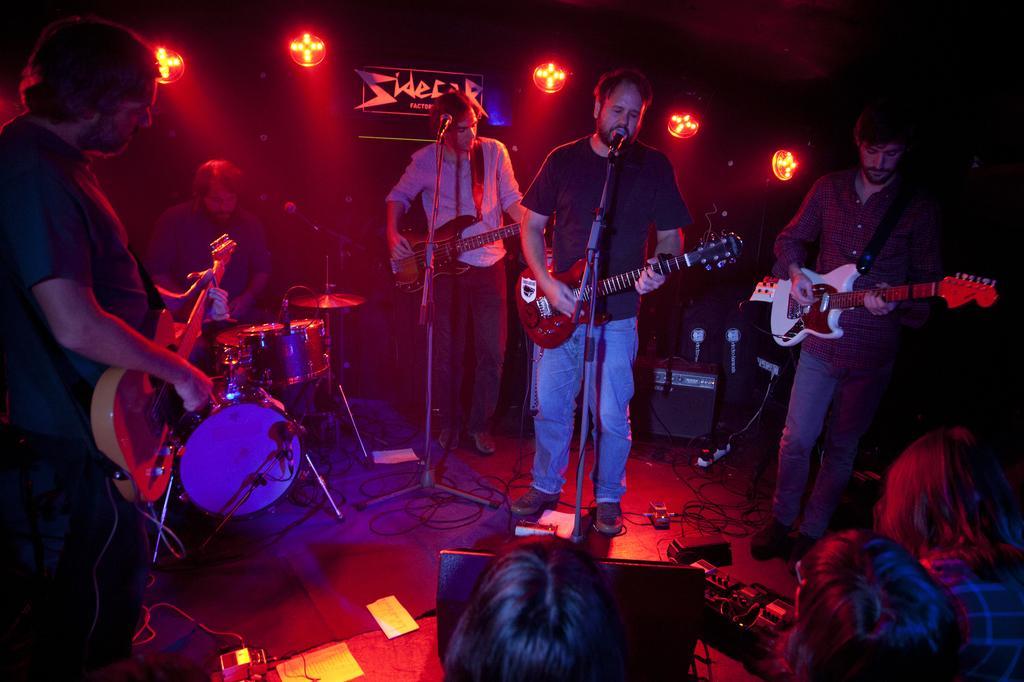Could you give a brief overview of what you see in this image? In this image in the middle there is a man, he wears a t shirt, trouser, shoes, he is playing a guitar, in front of him there is a mic. On the right there is a man, he wears a shirt, trouser, shoes, he is playing a guitar. On the left there is a man, he wears a shirt, trouser, shoes, he is playing a guitar, in front of him there is a mic. On the left there is a man, he wears a t shirt, trouser, shoes, he is playing a guitar. At the bottom there are some people, musical instruments, cables and papers. At the top there are lights and poster. 